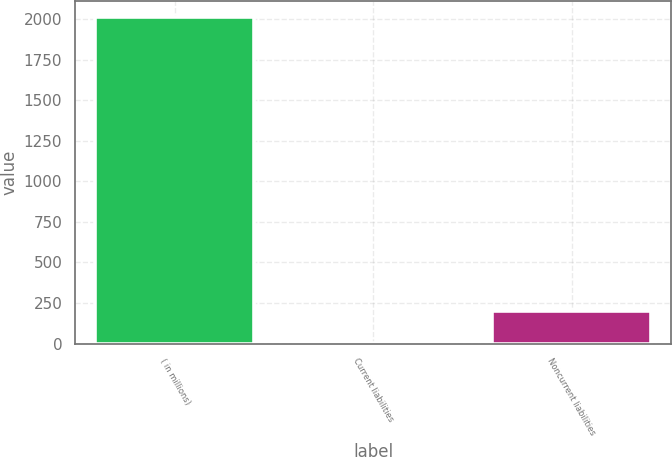Convert chart to OTSL. <chart><loc_0><loc_0><loc_500><loc_500><bar_chart><fcel>( in millions)<fcel>Current liabilities<fcel>Noncurrent liabilities<nl><fcel>2010<fcel>1.1<fcel>201.99<nl></chart> 